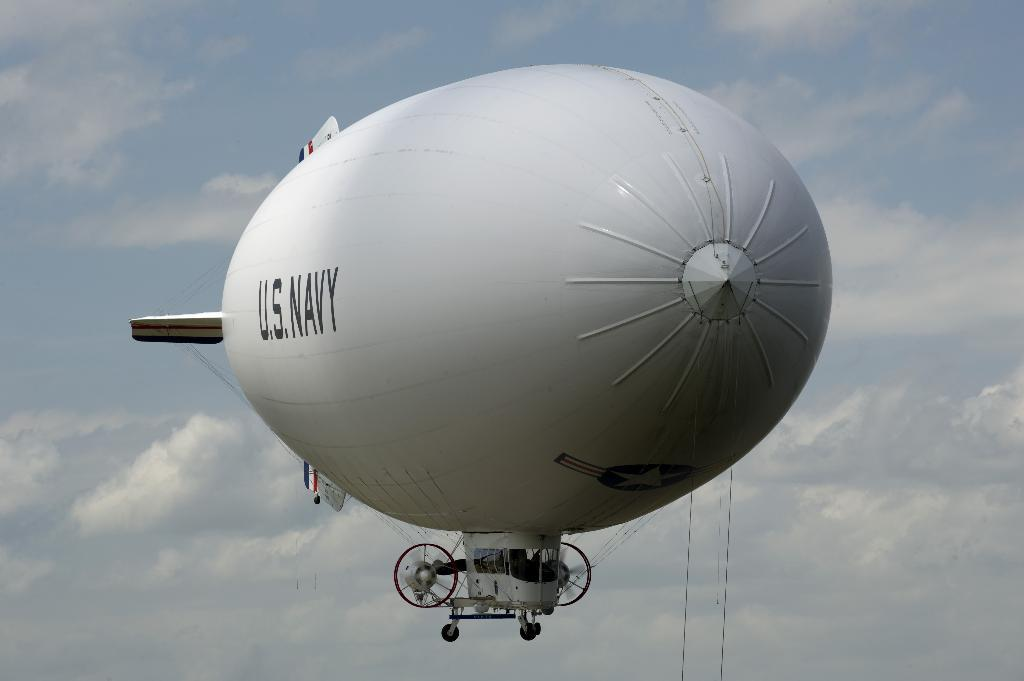<image>
Summarize the visual content of the image. a US Navy blimp is in the cloudy sky 